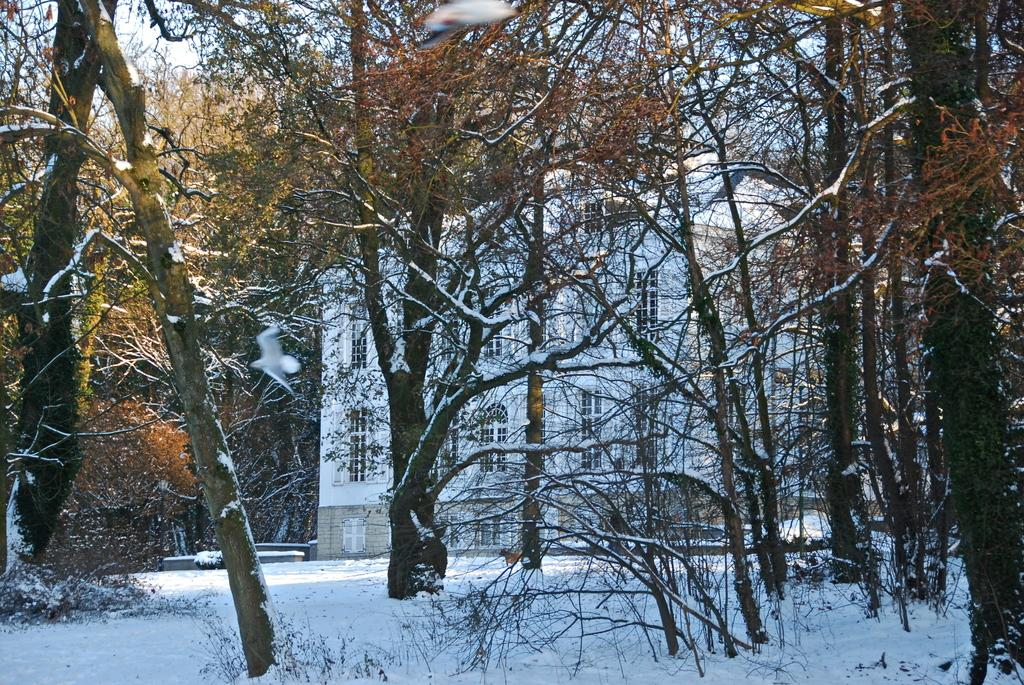What is the main structure in the center of the image? There is a white building in the center of the image. What type of vegetation surrounds the white building? Trees are surrounding the white building. What is the ground covered with at the bottom of the image? There is snow at the bottom of the image. What can be seen in the background of the image? The sky is visible in the background of the image. Where is the police officer writing in their notebook in the image? There is no police officer or notebook present in the image. Is there a lake visible in the image? There is no lake present in the image. 